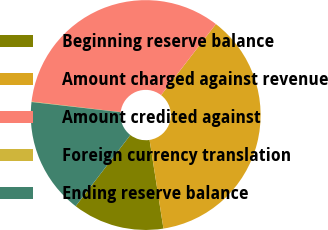Convert chart. <chart><loc_0><loc_0><loc_500><loc_500><pie_chart><fcel>Beginning reserve balance<fcel>Amount charged against revenue<fcel>Amount credited against<fcel>Foreign currency translation<fcel>Ending reserve balance<nl><fcel>12.9%<fcel>37.07%<fcel>33.59%<fcel>0.06%<fcel>16.38%<nl></chart> 